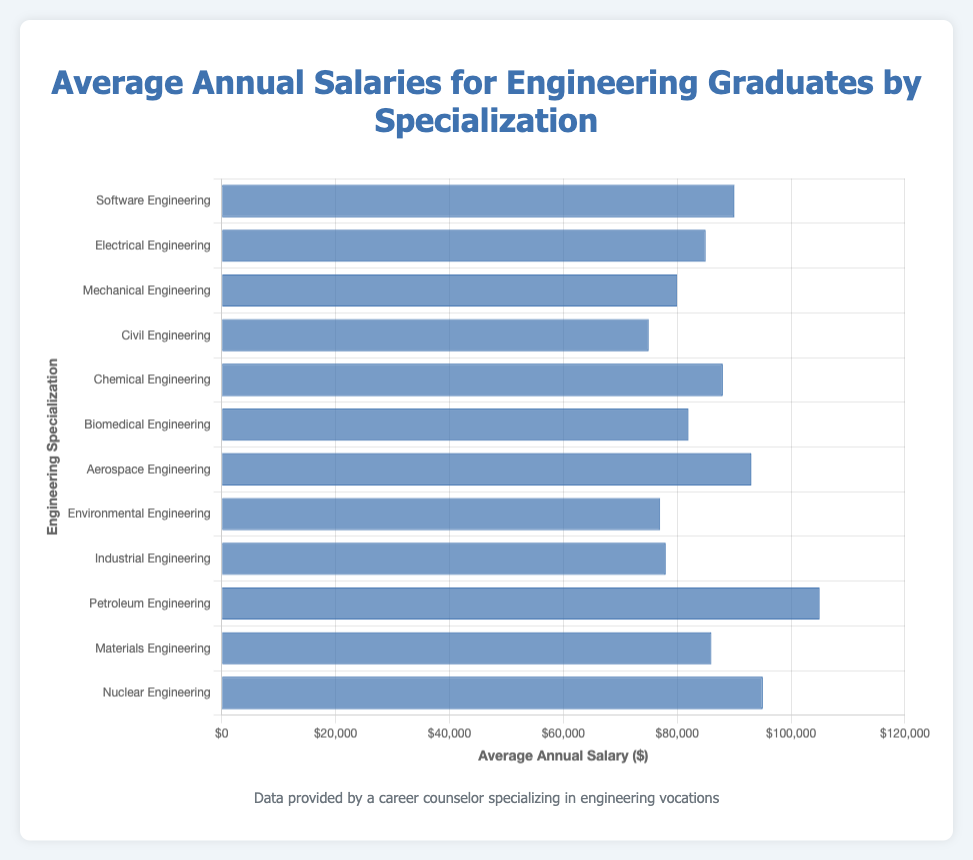what is the highest average annual salary for engineering graduates by specialization? The highest average annual salary can be easily seen by identifying which bar reaches the farthest to the right. The specialization with the highest value is Petroleum Engineering at $105,000.
Answer: $105,000 which specialization has the lowest average annual salary? To find the lowest average annual salary, look for the bar that is the shortest. Civil Engineering has the lowest average salary of $75,000.
Answer: $75,000 how much higher is the average annual salary for software engineering compared to civil engineering? To find the difference, subtract the salary of Civil Engineering from Software Engineering. Software Engineering: $90,000 - Civil Engineering: $75,000 = $15,000.
Answer: $15,000 which specializations have an average annual salary greater than $90,000? To identify these, look for bars extending past the $90,000 mark. These are Aerospace Engineering ($93,000), Petroleum Engineering ($105,000), and Nuclear Engineering ($95,000).
Answer: Aerospace Engineering, Petroleum Engineering, Nuclear Engineering what is the average annual salary for chemical engineering and materials engineering combined? Add the average annual salaries for both specializations and then divide by 2 to get the average. (($88,000 + $86,000) / 2) = $87,000.
Answer: $87,000 between mechanical engineering and biomedical engineering, which has higher average annual salary and by how much? Compare the values: Mechanical Engineering ($80,000) and Biomedical Engineering ($82,000). Subtract to find the difference. $82,000 - $80,000 = $2,000.
Answer: Biomedical Engineering, $2,000 how many specializations have an average annual salary above $80,000? Count the number of specializations with bars extending beyond the $80,000 mark. The specializations are Software Engineering, Electrical Engineering, Chemical Engineering, Biomedical Engineering, Aerospace Engineering, Petroleum Engineering, Materials Engineering, and Nuclear Engineering. Total count is 8.
Answer: 8 what is the total average annual salary for electrical engineering, mechanical engineering, and civil engineering? Add the salaries of these three specializations: Electrical Engineering ($85,000), Mechanical Engineering ($80,000), and Civil Engineering ($75,000). The total is $85,000 + $80,000 + $75,000 = $240,000.
Answer: $240,000 how does the average annual salary for environmental engineering compare to that of industrial engineering? Compare the values: Environmental Engineering ($77,000) and Industrial Engineering ($78,000). Environmental Engineering has an annual salary of $1,000 less than Industrial Engineering.
Answer: Environmental Engineering is $1,000 less what visual elements highlight the engineering specialization with the highest average annual salary? Look for visual elements like the length of the bar and positioning. The specialization with the highest average annual salary is highlighted by the longest bar, which extends furthest to the right compared to others.
Answer: Longest bar, furthest to the right 